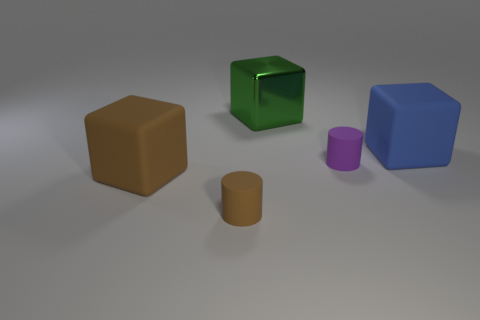There is another thing that is the same size as the purple rubber thing; what is it made of? rubber 